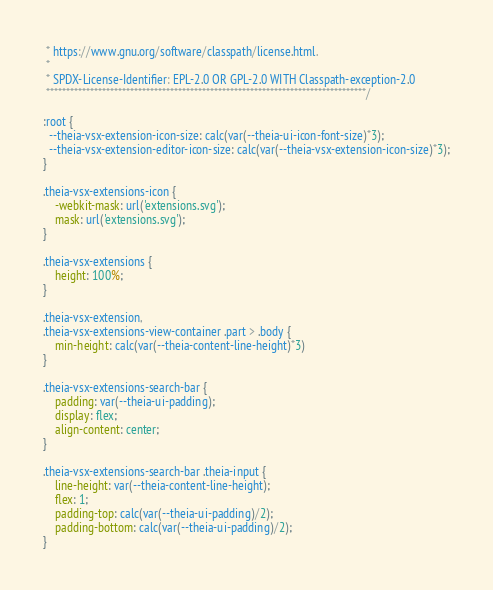Convert code to text. <code><loc_0><loc_0><loc_500><loc_500><_CSS_> * https://www.gnu.org/software/classpath/license.html.
 *
 * SPDX-License-Identifier: EPL-2.0 OR GPL-2.0 WITH Classpath-exception-2.0
 ********************************************************************************/

:root {
  --theia-vsx-extension-icon-size: calc(var(--theia-ui-icon-font-size)*3);
  --theia-vsx-extension-editor-icon-size: calc(var(--theia-vsx-extension-icon-size)*3);
}

.theia-vsx-extensions-icon {
    -webkit-mask: url('extensions.svg');
    mask: url('extensions.svg');
}

.theia-vsx-extensions {
    height: 100%;
}

.theia-vsx-extension,
.theia-vsx-extensions-view-container .part > .body {
    min-height: calc(var(--theia-content-line-height)*3)
}

.theia-vsx-extensions-search-bar {
    padding: var(--theia-ui-padding);
    display: flex;
    align-content: center;
}

.theia-vsx-extensions-search-bar .theia-input {
    line-height: var(--theia-content-line-height);
    flex: 1;
    padding-top: calc(var(--theia-ui-padding)/2);
    padding-bottom: calc(var(--theia-ui-padding)/2);
}
</code> 